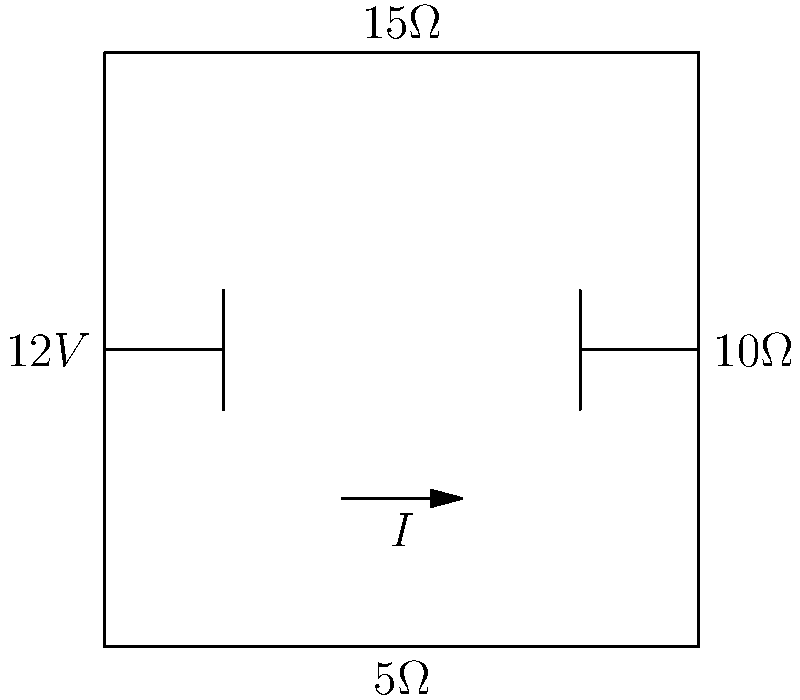In the given DC circuit, determine the current $I$ flowing through the circuit. How might this analysis be relevant when designing an employee recognition system that uses electronic displays? To solve this problem, we'll use Ohm's Law and the concept of total resistance in a series circuit. This analysis is relevant to designing electronic displays for employee recognition systems, as understanding current flow is crucial for proper functioning and power management of such devices.

Step 1: Calculate the total resistance ($R_{total}$) in the circuit.
In a series circuit, the total resistance is the sum of all individual resistances:
$R_{total} = 5\Omega + 10\Omega + 15\Omega = 30\Omega$

Step 2: Apply Ohm's Law to find the current.
Ohm's Law states that $V = IR$, where $V$ is voltage, $I$ is current, and $R$ is resistance.
Rearranging the equation to solve for $I$:
$I = \frac{V}{R_{total}} = \frac{12V}{30\Omega} = 0.4A$

Step 3: Interpret the result.
The current flowing through the circuit is 0.4 amperes or 400 milliamperes.

In the context of employee recognition systems, this analysis is important for:
1. Ensuring proper power supply for electronic displays
2. Calculating battery life for portable recognition devices
3. Designing energy-efficient circuits for long-term use
4. Preventing overheating or damage to components
5. Optimizing brightness and performance of LED or LCD displays used in recognition boards or digital badges
Answer: $I = 0.4A$ 